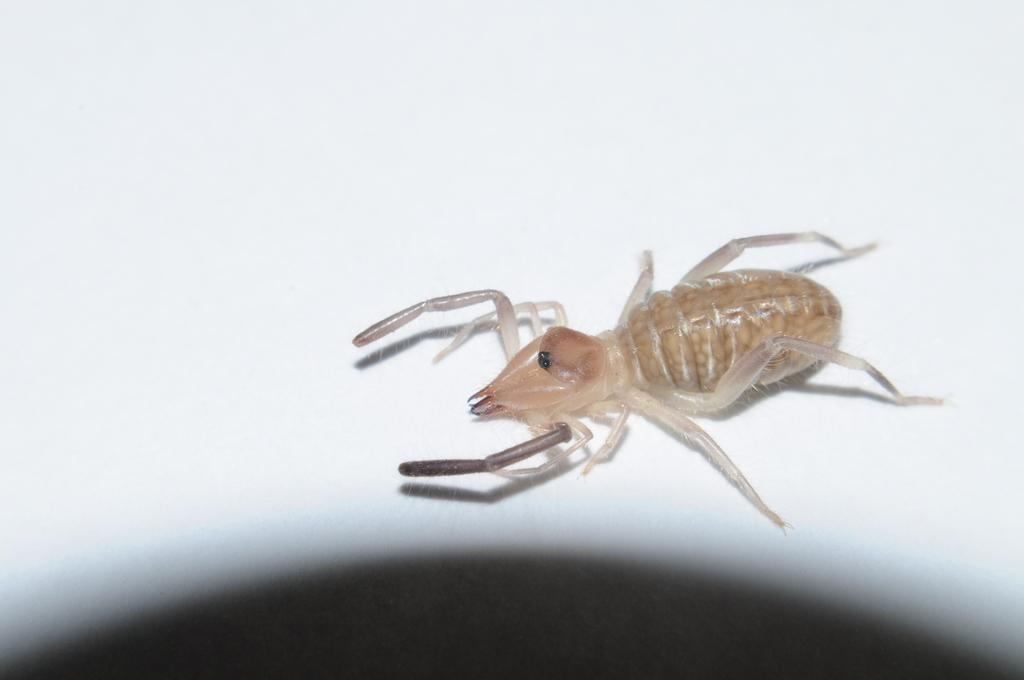What type of creature is in the image? There is an insect in the image. What is the background or surface that the insect is on? The insect is on a white surface. What color is the insect? The insect is brown in color. What letter does the robin bring in the image? There is no robin present in the image, and therefore no letter can be delivered. 